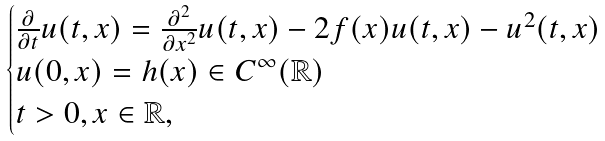Convert formula to latex. <formula><loc_0><loc_0><loc_500><loc_500>\begin{cases} \frac { \partial } { \partial t } u ( t , x ) = \frac { \partial ^ { 2 } } { \partial x ^ { 2 } } u ( t , x ) - 2 f ( x ) u ( t , x ) - u ^ { 2 } ( t , x ) \\ u ( 0 , x ) = h ( x ) \in C ^ { \infty } ( \mathbb { R } ) \\ t > 0 , x \in \mathbb { R } , \\ \end{cases}</formula> 